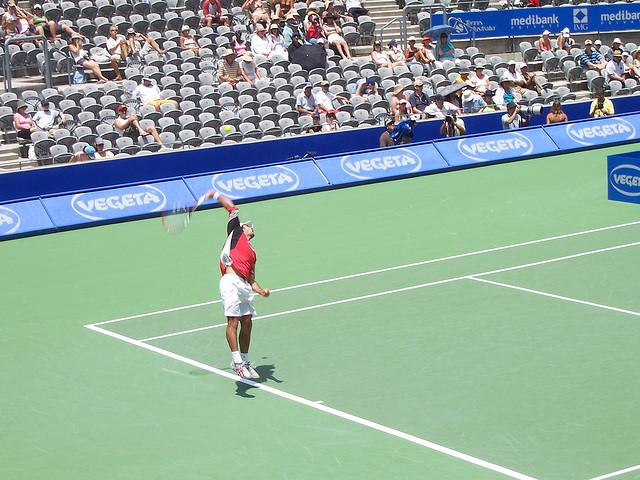What is the brand advertising along the sides of the court? vegeta 